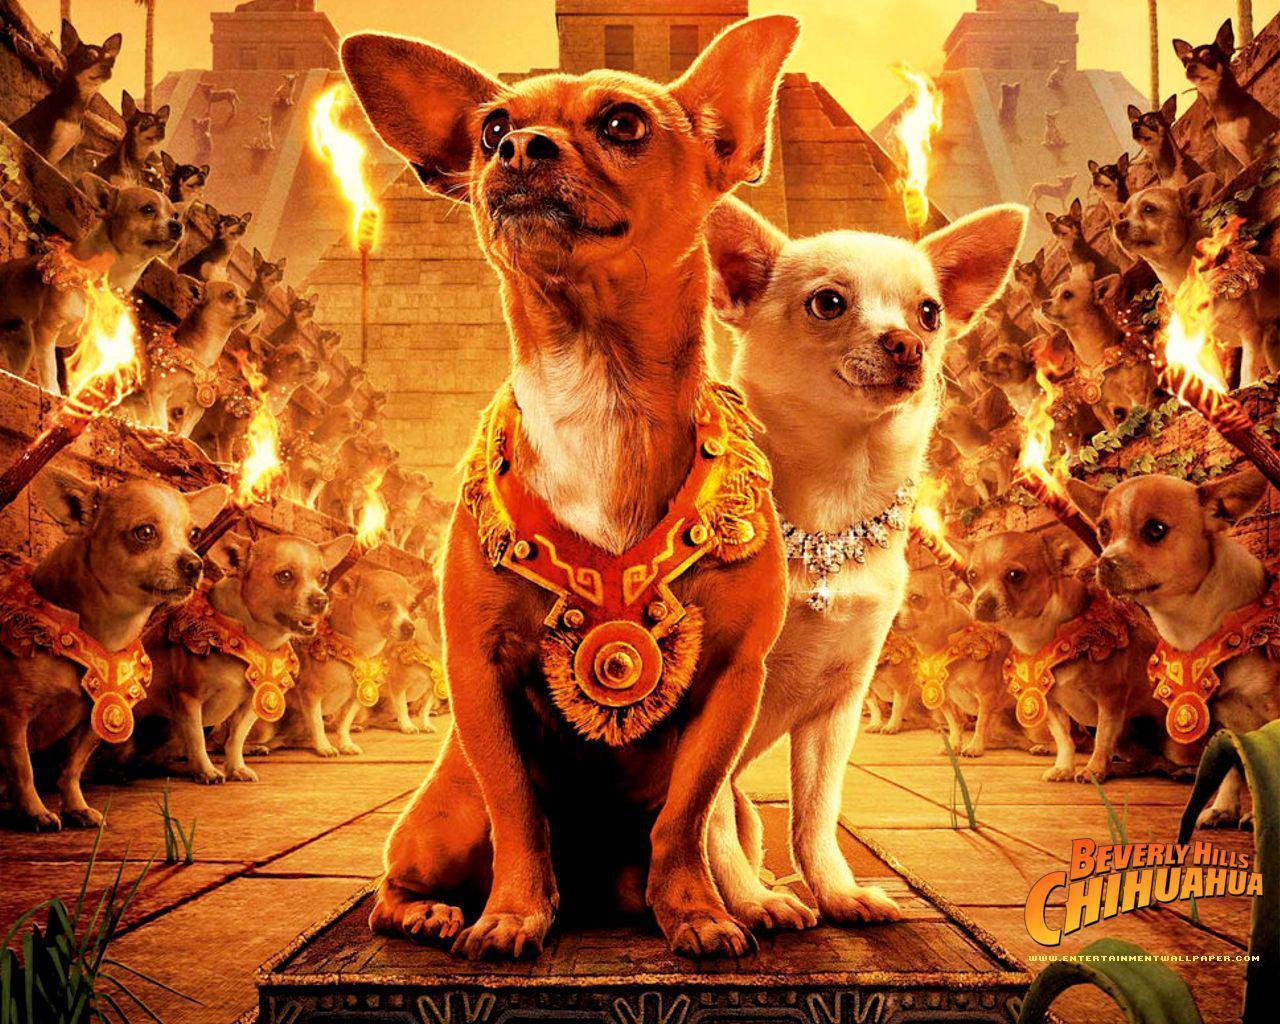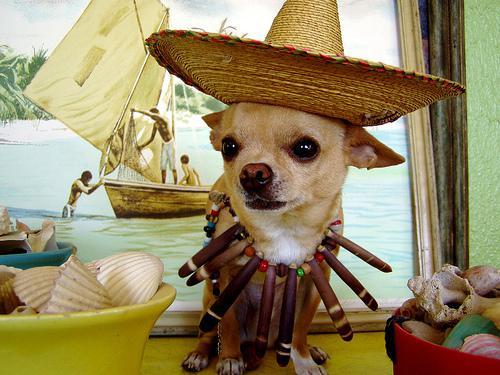The first image is the image on the left, the second image is the image on the right. Evaluate the accuracy of this statement regarding the images: "The images contain at least one row of chihuauas wearing something ornate around their necks and include at least one dog wearing a type of hat.". Is it true? Answer yes or no. Yes. 